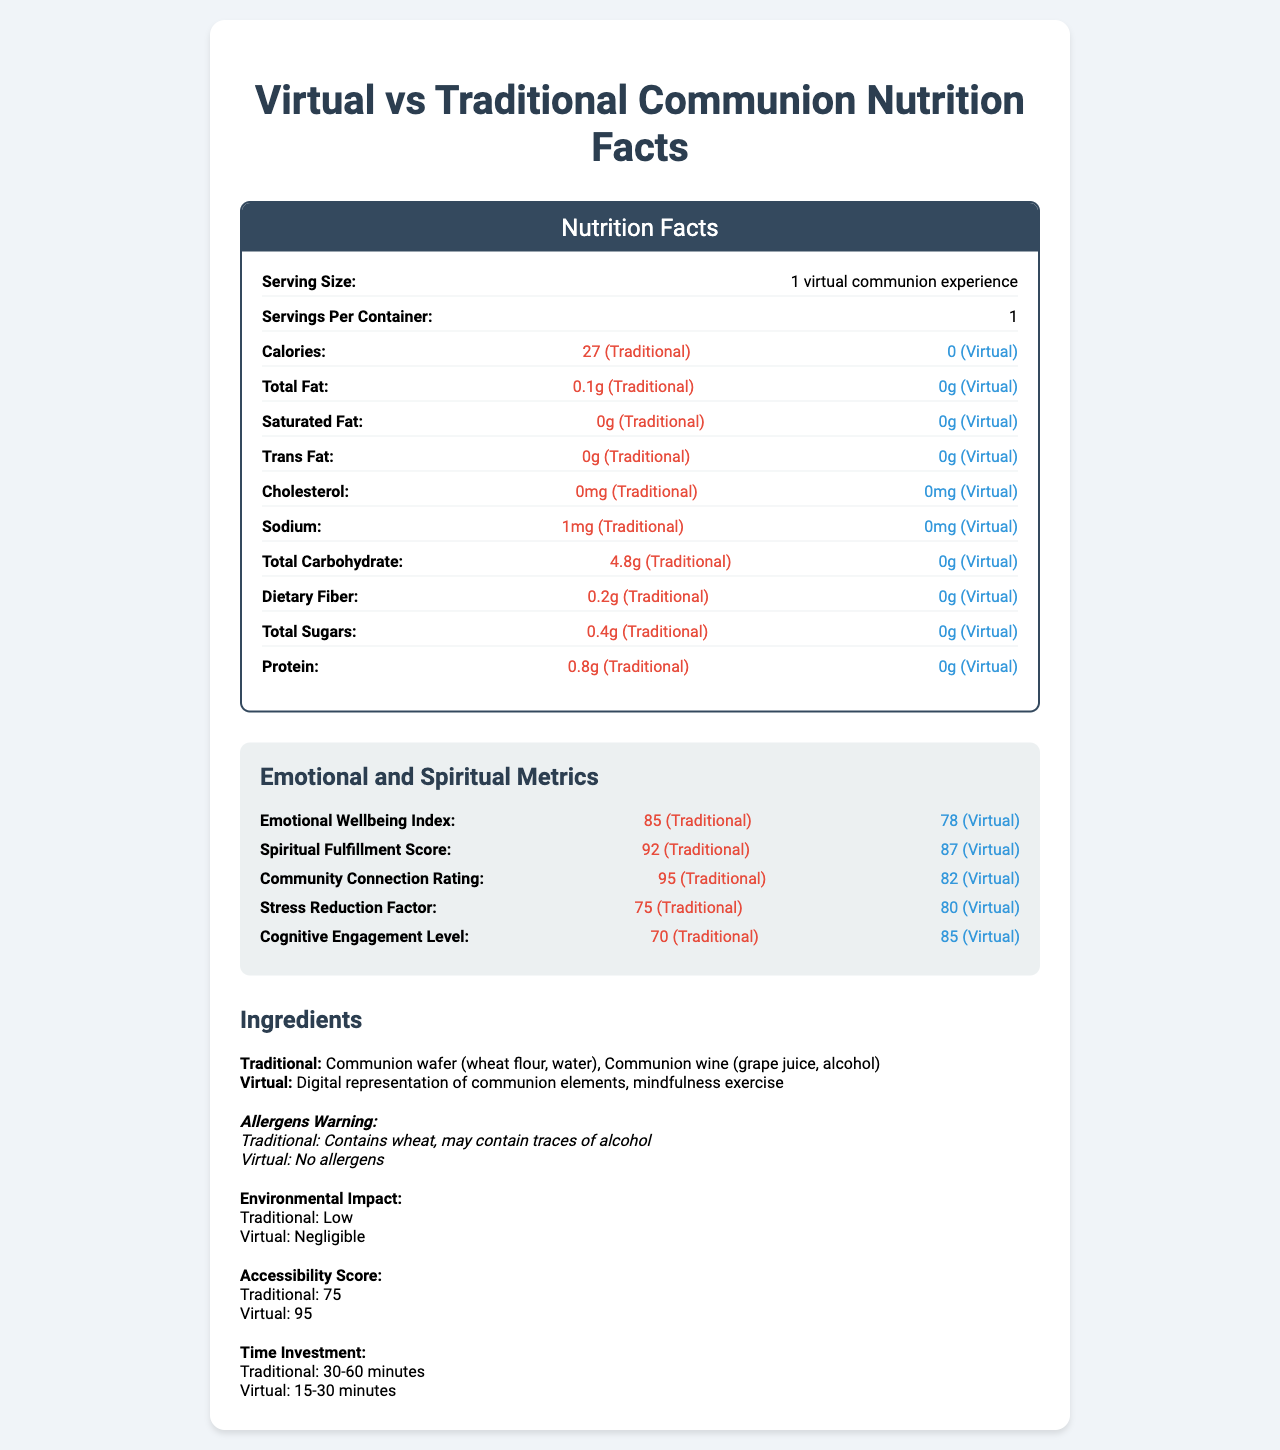what is the serving size for a virtual communion experience? The document states that the serving size is "1 virtual communion experience".
Answer: 1 virtual communion experience how many calories are there in a traditional communion experience? The document shows that there are 27 calories per serving in a traditional communion experience.
Answer: 27 calories how many calories are there in a virtual communion experience? The document indicates that a virtual communion experience has 0 calories per serving.
Answer: 0 calories what is the total carbohydrate content in a traditional communion? The document lists the total carbohydrate content for a traditional communion at 4.8g.
Answer: 4.8g how much protein is in a virtual communion experience? According to the document, a virtual communion experience contains 0g of protein.
Answer: 0g what is the emotional wellbeing index for a traditional communion? The document lists the emotional wellbeing index for a traditional communion as 85.
Answer: 85 which has a higher spiritual fulfillment score, traditional or virtual communion? The document shows that traditional communion has a spiritual fulfillment score of 92, whereas virtual communion has a score of 87.
Answer: Traditional communion which type of communion has a higher cognitive engagement level? A. Traditional B. Virtual The document demonstrates that the cognitive engagement level is 85 for virtual communion and 70 for traditional communion, making virtual communion higher.
Answer: B. Virtual what is the community connection rating for virtual communion? A. 78 B. 82 C. 87 The document indicates that the community connection rating for virtual communion is 82.
Answer: B. 82 what is the total fat content in a traditional communion? The document shows that the total fat content in a traditional communion is 0.1g.
Answer: 0.1g are there any allergens in virtual communion? The document states that there are no allergens in a virtual communion experience.
Answer: No how long does a traditional communion usually take? The document mentions that the time investment for a traditional communion is 30-60 minutes.
Answer: 30-60 minutes how long does a virtual communion typically take? The document shows that the time investment for a virtual communion is 15-30 minutes.
Answer: 15-30 minutes does virtual communion have any sodium content? Yes/No The document specifies that virtual communion has 0mg of sodium.
Answer: No describe the main differences between traditional and virtual communion in terms of nutritional content and emotional/spiritual metrics Traditional communion has caloric, fat, carbohydrate, and protein content, whereas virtual communion does not. Emotionally, traditional communion rates higher in wellbeing, fulfillment, and connection, while virtual communion excels in stress reduction and cognitive engagement.
Answer: Traditional communion involves actual food elements with calories, fat, carbohydrates, and protein, whereas virtual communion has none of these. Emotionally and spiritually, traditional communion scores higher on emotional wellbeing, spiritual fulfillment, and community connection, but virtual communion has a higher score for stress reduction and cognitive engagement. what is the traditional communion ingredient list? The document lists the ingredients for traditional communion as "Communion wafer (wheat flour, water), Communion wine (grape juice, alcohol)".
Answer: Communion wafer (wheat flour, water), Communion wine (grape juice, alcohol) what is the environmental impact of virtual communion? The document states that the environmental impact of virtual communion is negligible.
Answer: Negligible what is the accessibility score for virtual communion? The document indicates that the accessibility score for virtual communion is 95.
Answer: 95 how closely connected do participants feel to their community in virtual communion compared to traditional communion? The document shows that the community connection rating is 95 for traditional communion and 82 for virtual communion, meaning participants feel less closely connected in virtual communion.
Answer: Less closely connected in virtual communion does traditional communion reduce stress more effectively than virtual communion? According to the document, the stress reduction factor is higher for virtual communion (80) compared to traditional communion (75).
Answer: No which has higher cholesterol content, traditional or virtual communion? Both types of communion have 0mg of cholesterol as stated in the document.
Answer: Neither does the document provide information on how communion affects long-term mental health? The document does not provide details on the long-term mental health effects of communion.
Answer: Not enough information 